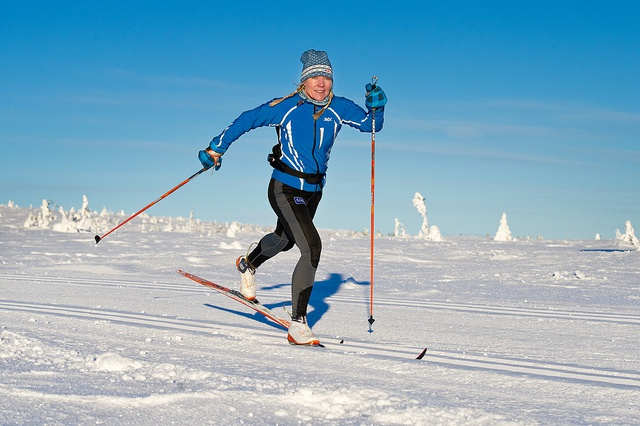Describe the objects in this image and their specific colors. I can see people in teal, blue, black, gray, and lightgray tones and skis in teal, lightgray, darkgray, brown, and tan tones in this image. 